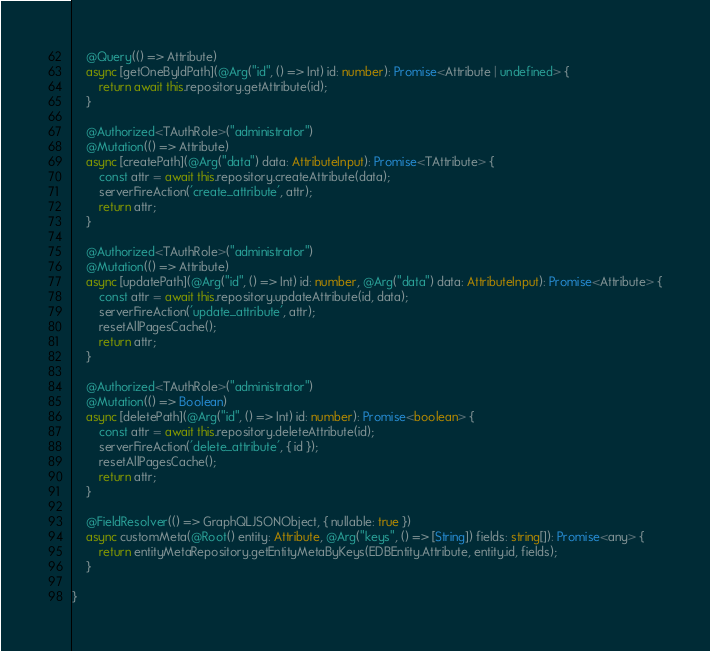Convert code to text. <code><loc_0><loc_0><loc_500><loc_500><_TypeScript_>    @Query(() => Attribute)
    async [getOneByIdPath](@Arg("id", () => Int) id: number): Promise<Attribute | undefined> {
        return await this.repository.getAttribute(id);
    }

    @Authorized<TAuthRole>("administrator")
    @Mutation(() => Attribute)
    async [createPath](@Arg("data") data: AttributeInput): Promise<TAttribute> {
        const attr = await this.repository.createAttribute(data);
        serverFireAction('create_attribute', attr);
        return attr;
    }

    @Authorized<TAuthRole>("administrator")
    @Mutation(() => Attribute)
    async [updatePath](@Arg("id", () => Int) id: number, @Arg("data") data: AttributeInput): Promise<Attribute> {
        const attr = await this.repository.updateAttribute(id, data);
        serverFireAction('update_attribute', attr);
        resetAllPagesCache();
        return attr;
    }

    @Authorized<TAuthRole>("administrator")
    @Mutation(() => Boolean)
    async [deletePath](@Arg("id", () => Int) id: number): Promise<boolean> {
        const attr = await this.repository.deleteAttribute(id);
        serverFireAction('delete_attribute', { id });
        resetAllPagesCache();
        return attr;
    }

    @FieldResolver(() => GraphQLJSONObject, { nullable: true })
    async customMeta(@Root() entity: Attribute, @Arg("keys", () => [String]) fields: string[]): Promise<any> {
        return entityMetaRepository.getEntityMetaByKeys(EDBEntity.Attribute, entity.id, fields);
    }

}</code> 